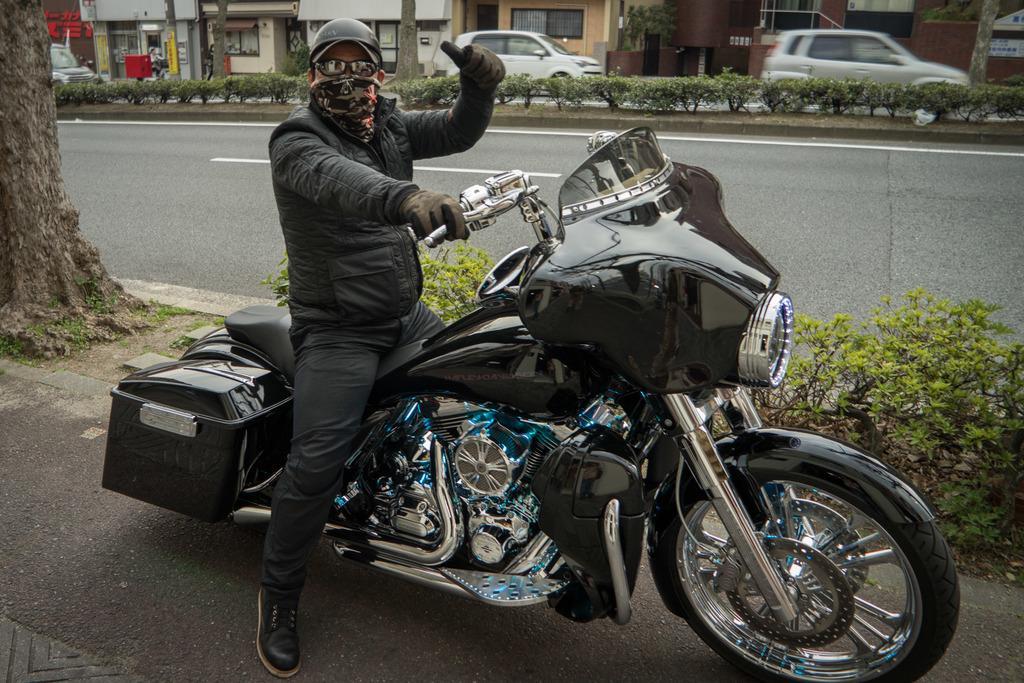Please provide a concise description of this image. In the given image we can see a man sitting on a bike. He is wearing a black color jacket and helmet. This is a tree trunk, plant, building and cars. 